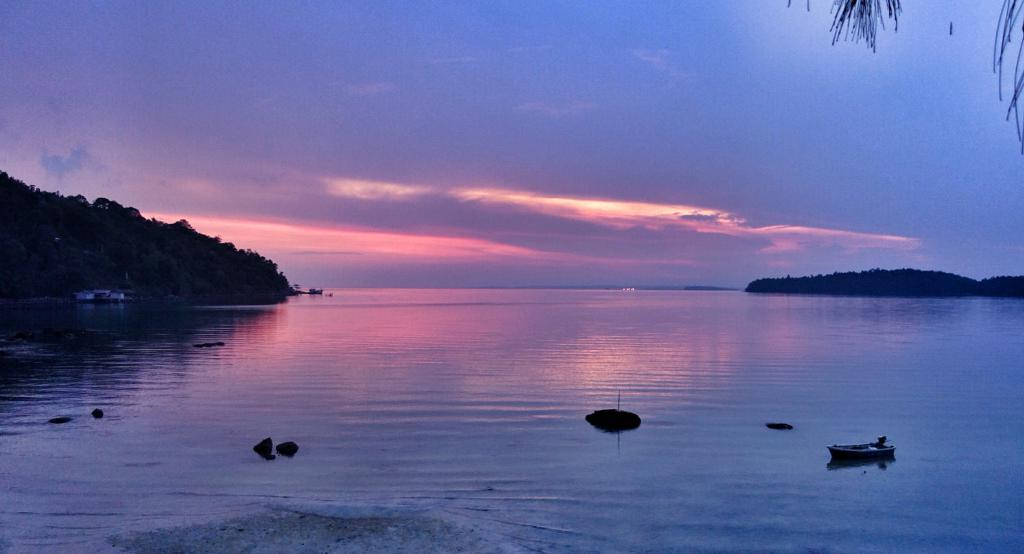What is in the water in the image? There are boats in the water in the image. What type of vegetation can be seen in the image? There are trees visible in the image. What part of the natural environment is visible in the background of the image? The sky is visible in the background of the image. What type of band is playing music in the image? There is no band present in the image; it features boats in the water and trees. What force is responsible for the movement of the boats in the image? The image does not show the boats in motion, so it is not possible to determine the force responsible for their movement. 